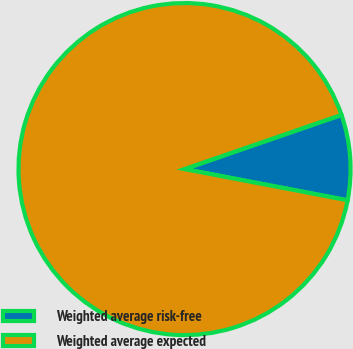Convert chart to OTSL. <chart><loc_0><loc_0><loc_500><loc_500><pie_chart><fcel>Weighted average risk-free<fcel>Weighted average expected<nl><fcel>8.3%<fcel>91.7%<nl></chart> 